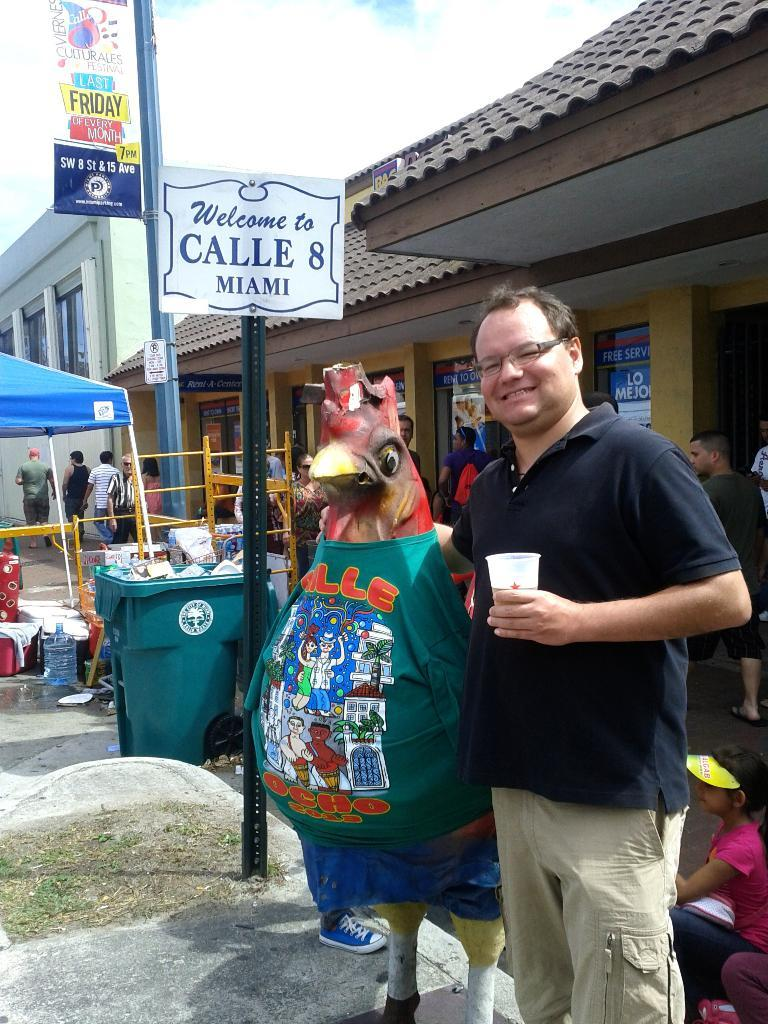<image>
Relay a brief, clear account of the picture shown. Man standing with a chicken outside and a sign that says Welcome to Calle 8 Miami. 